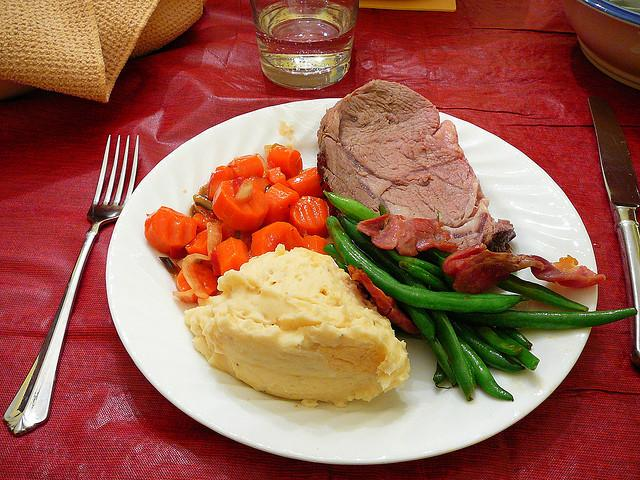What is a healthy item on the plate?

Choices:
A) chicken leg
B) lemon
C) guava
D) carrot carrot 